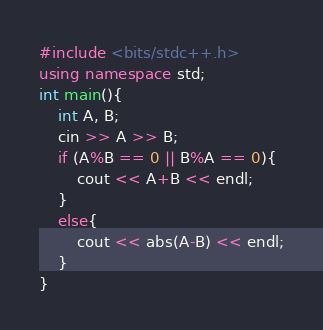Convert code to text. <code><loc_0><loc_0><loc_500><loc_500><_C++_>#include <bits/stdc++.h>
using namespace std;
int main(){
    int A, B;
    cin >> A >> B;
    if (A%B == 0 || B%A == 0){
        cout << A+B << endl;
    }
    else{
        cout << abs(A-B) << endl;
    }
}</code> 